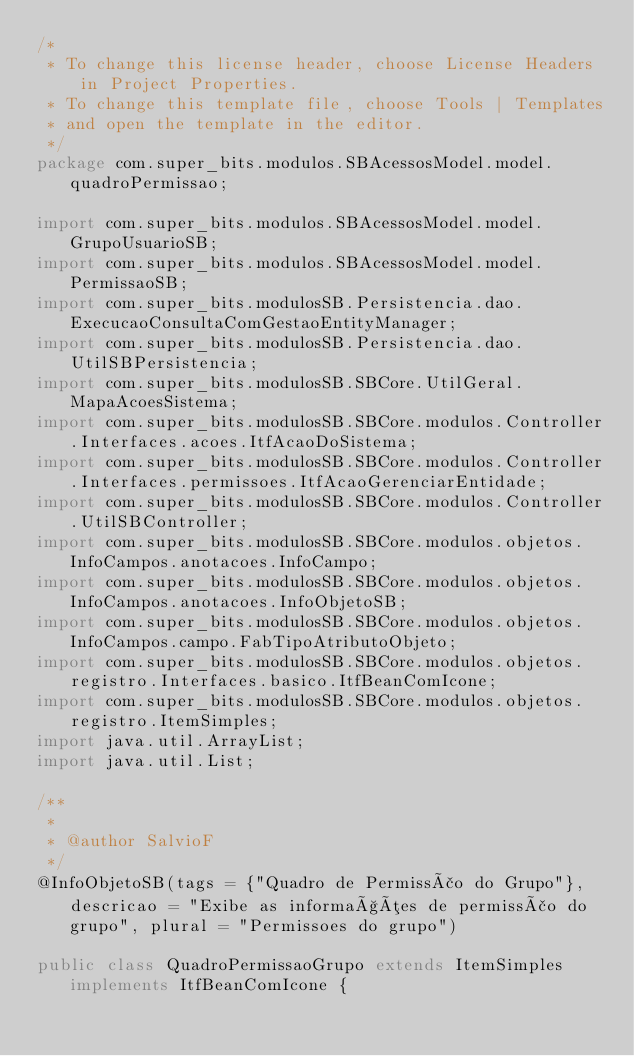Convert code to text. <code><loc_0><loc_0><loc_500><loc_500><_Java_>/*
 * To change this license header, choose License Headers in Project Properties.
 * To change this template file, choose Tools | Templates
 * and open the template in the editor.
 */
package com.super_bits.modulos.SBAcessosModel.model.quadroPermissao;

import com.super_bits.modulos.SBAcessosModel.model.GrupoUsuarioSB;
import com.super_bits.modulos.SBAcessosModel.model.PermissaoSB;
import com.super_bits.modulosSB.Persistencia.dao.ExecucaoConsultaComGestaoEntityManager;
import com.super_bits.modulosSB.Persistencia.dao.UtilSBPersistencia;
import com.super_bits.modulosSB.SBCore.UtilGeral.MapaAcoesSistema;
import com.super_bits.modulosSB.SBCore.modulos.Controller.Interfaces.acoes.ItfAcaoDoSistema;
import com.super_bits.modulosSB.SBCore.modulos.Controller.Interfaces.permissoes.ItfAcaoGerenciarEntidade;
import com.super_bits.modulosSB.SBCore.modulos.Controller.UtilSBController;
import com.super_bits.modulosSB.SBCore.modulos.objetos.InfoCampos.anotacoes.InfoCampo;
import com.super_bits.modulosSB.SBCore.modulos.objetos.InfoCampos.anotacoes.InfoObjetoSB;
import com.super_bits.modulosSB.SBCore.modulos.objetos.InfoCampos.campo.FabTipoAtributoObjeto;
import com.super_bits.modulosSB.SBCore.modulos.objetos.registro.Interfaces.basico.ItfBeanComIcone;
import com.super_bits.modulosSB.SBCore.modulos.objetos.registro.ItemSimples;
import java.util.ArrayList;
import java.util.List;

/**
 *
 * @author SalvioF
 */
@InfoObjetoSB(tags = {"Quadro de Permissão do Grupo"}, descricao = "Exibe as informações de permissão do grupo", plural = "Permissoes do grupo")

public class QuadroPermissaoGrupo extends ItemSimples implements ItfBeanComIcone {
</code> 